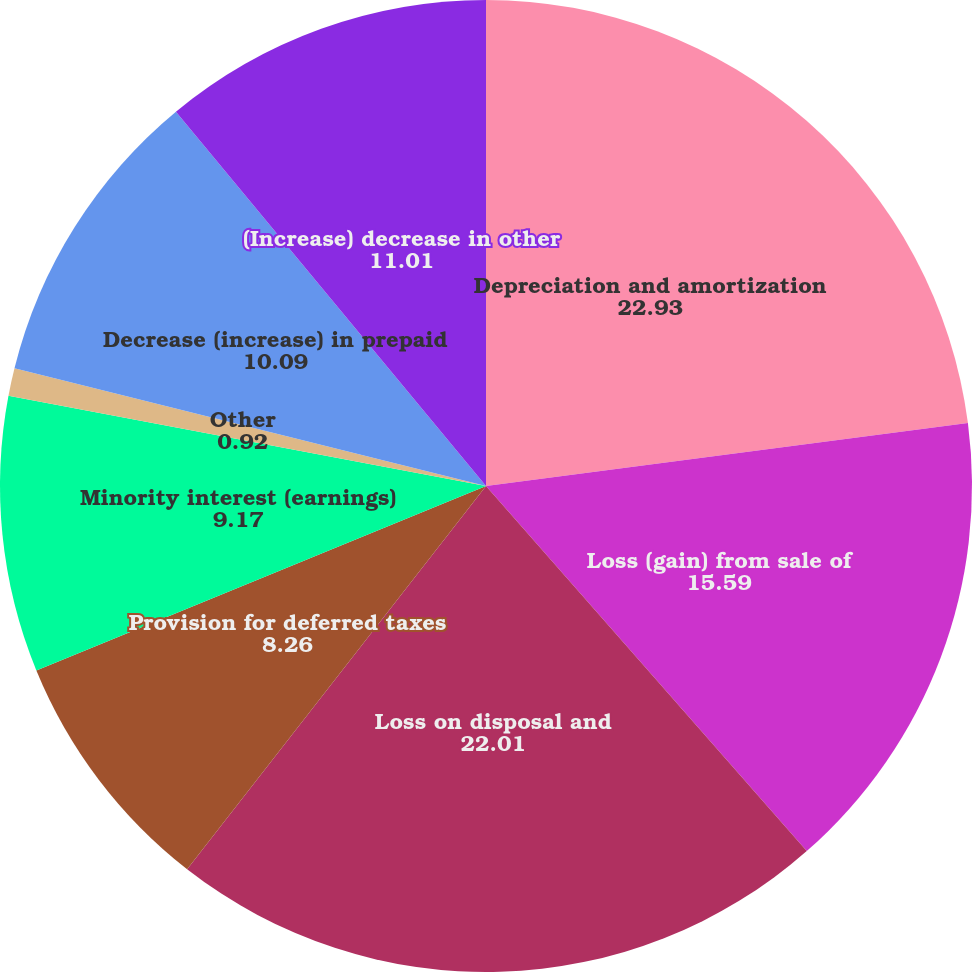Convert chart. <chart><loc_0><loc_0><loc_500><loc_500><pie_chart><fcel>Depreciation and amortization<fcel>Loss (gain) from sale of<fcel>Loss on disposal and<fcel>Provision for deferred taxes<fcel>Minority interest (earnings)<fcel>Other<fcel>(Increase) decrease in<fcel>Decrease (increase) in prepaid<fcel>(Increase) decrease in other<nl><fcel>22.93%<fcel>15.59%<fcel>22.01%<fcel>8.26%<fcel>9.17%<fcel>0.92%<fcel>0.0%<fcel>10.09%<fcel>11.01%<nl></chart> 